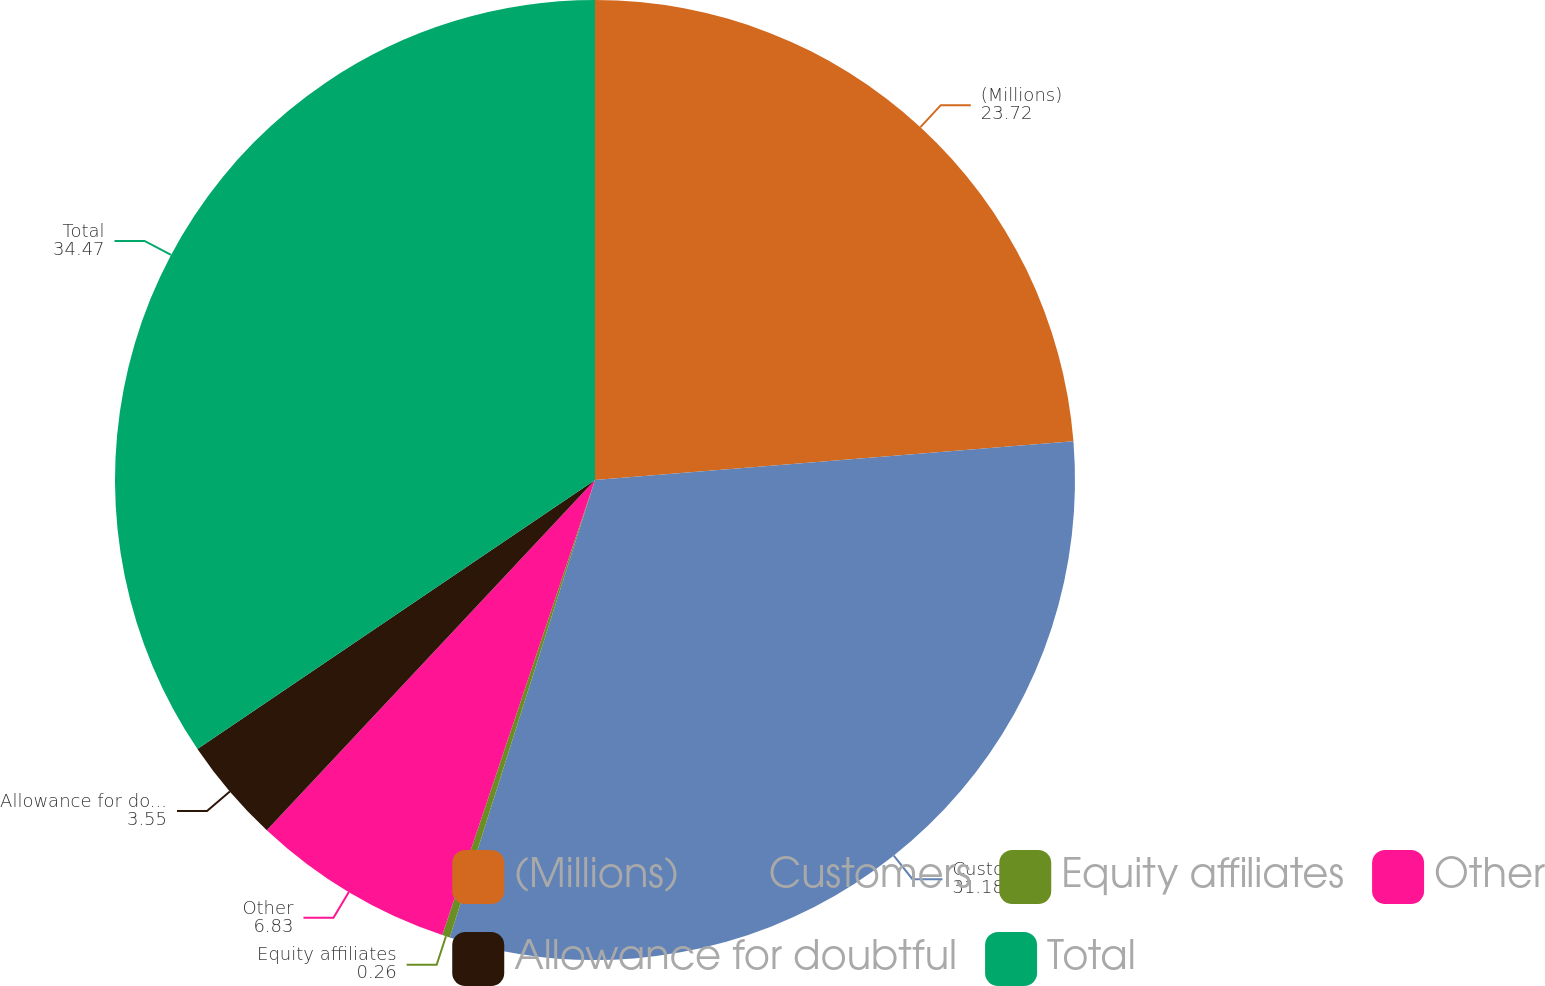Convert chart to OTSL. <chart><loc_0><loc_0><loc_500><loc_500><pie_chart><fcel>(Millions)<fcel>Customers<fcel>Equity affiliates<fcel>Other<fcel>Allowance for doubtful<fcel>Total<nl><fcel>23.72%<fcel>31.18%<fcel>0.26%<fcel>6.83%<fcel>3.55%<fcel>34.47%<nl></chart> 